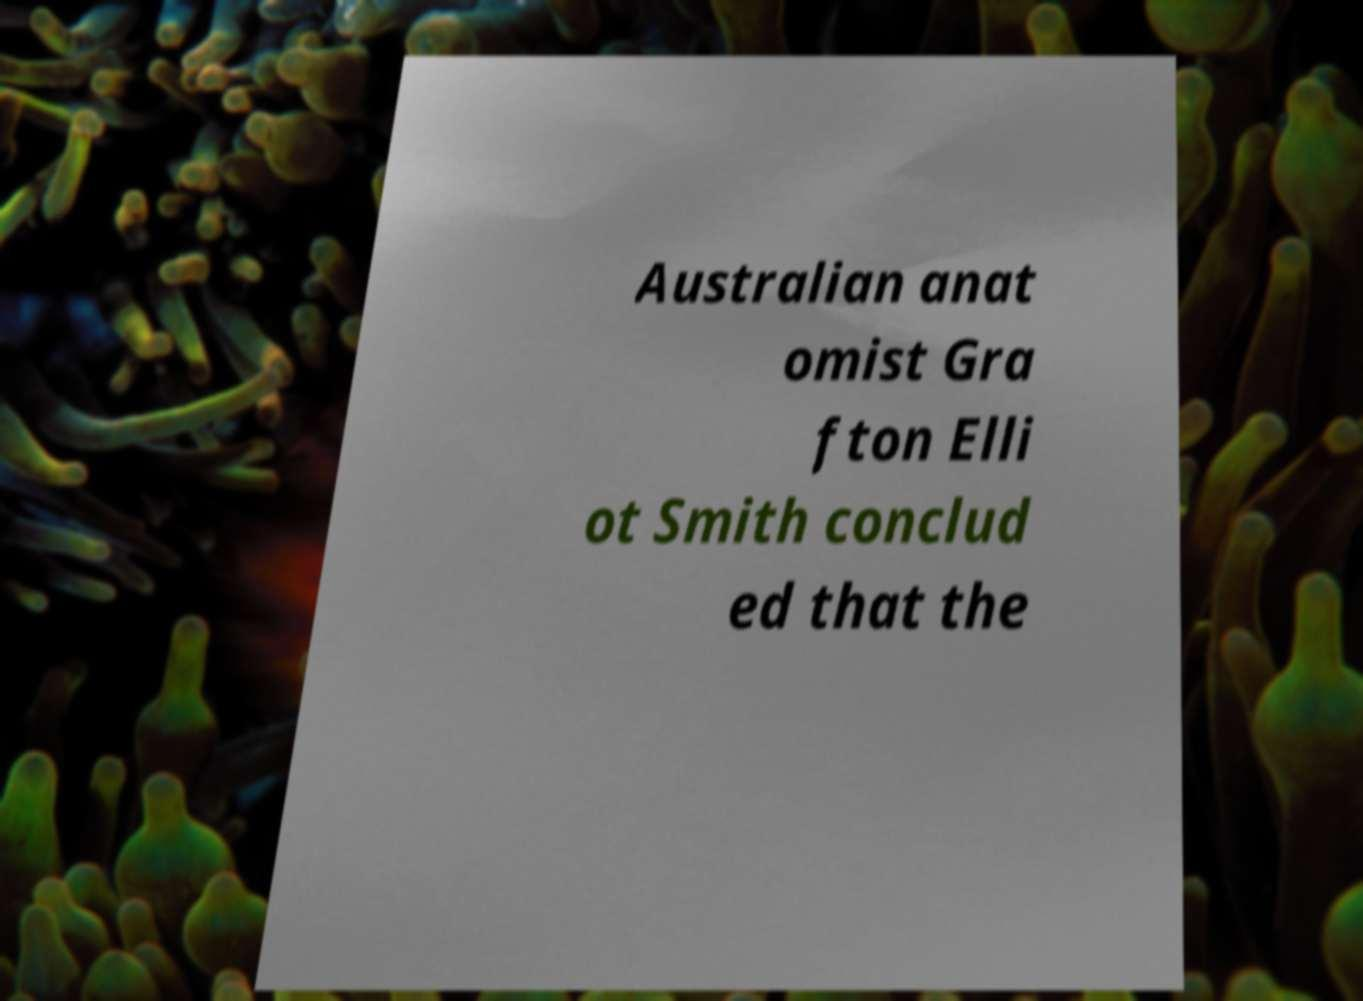I need the written content from this picture converted into text. Can you do that? Australian anat omist Gra fton Elli ot Smith conclud ed that the 